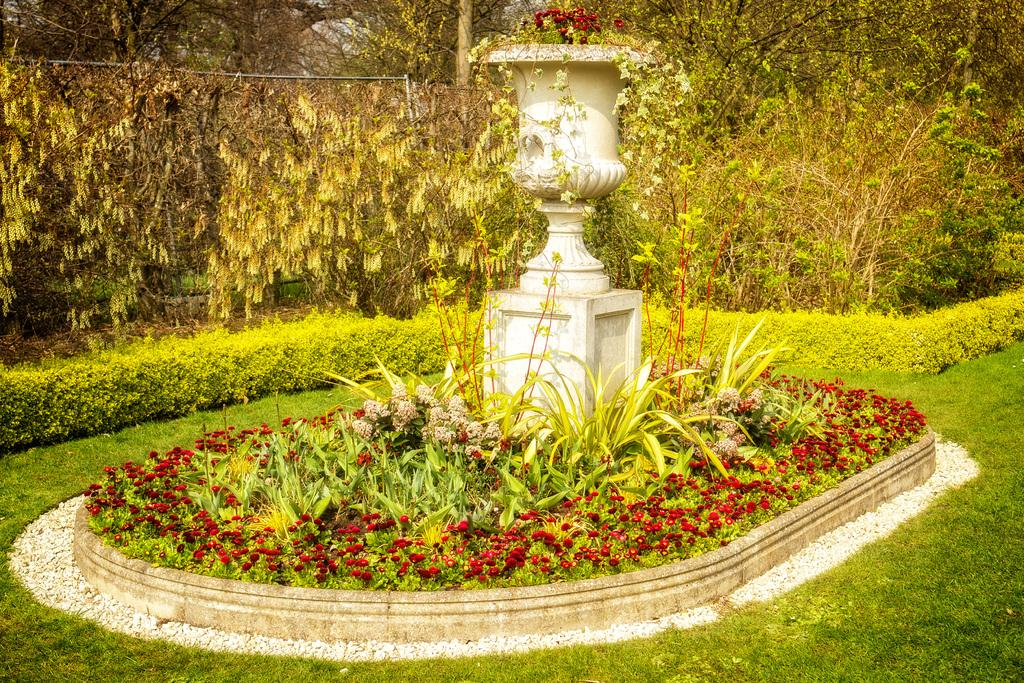What is the main feature in the picture? There is a fountain in the picture. What can be seen around the fountain? There are red flowers around the fountain. What is visible in the background of the picture? There are plants and trees in the background of the picture. What type of coach can be seen driving on the sidewalk in the image? There is no coach or sidewalk present in the image; it features a fountain with red flowers and a background of plants and trees. Can you spot a cat sitting on the fountain in the image? There is no cat present in the image; it only shows a fountain, red flowers, and a background of plants and trees. 